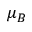<formula> <loc_0><loc_0><loc_500><loc_500>\mu _ { B }</formula> 